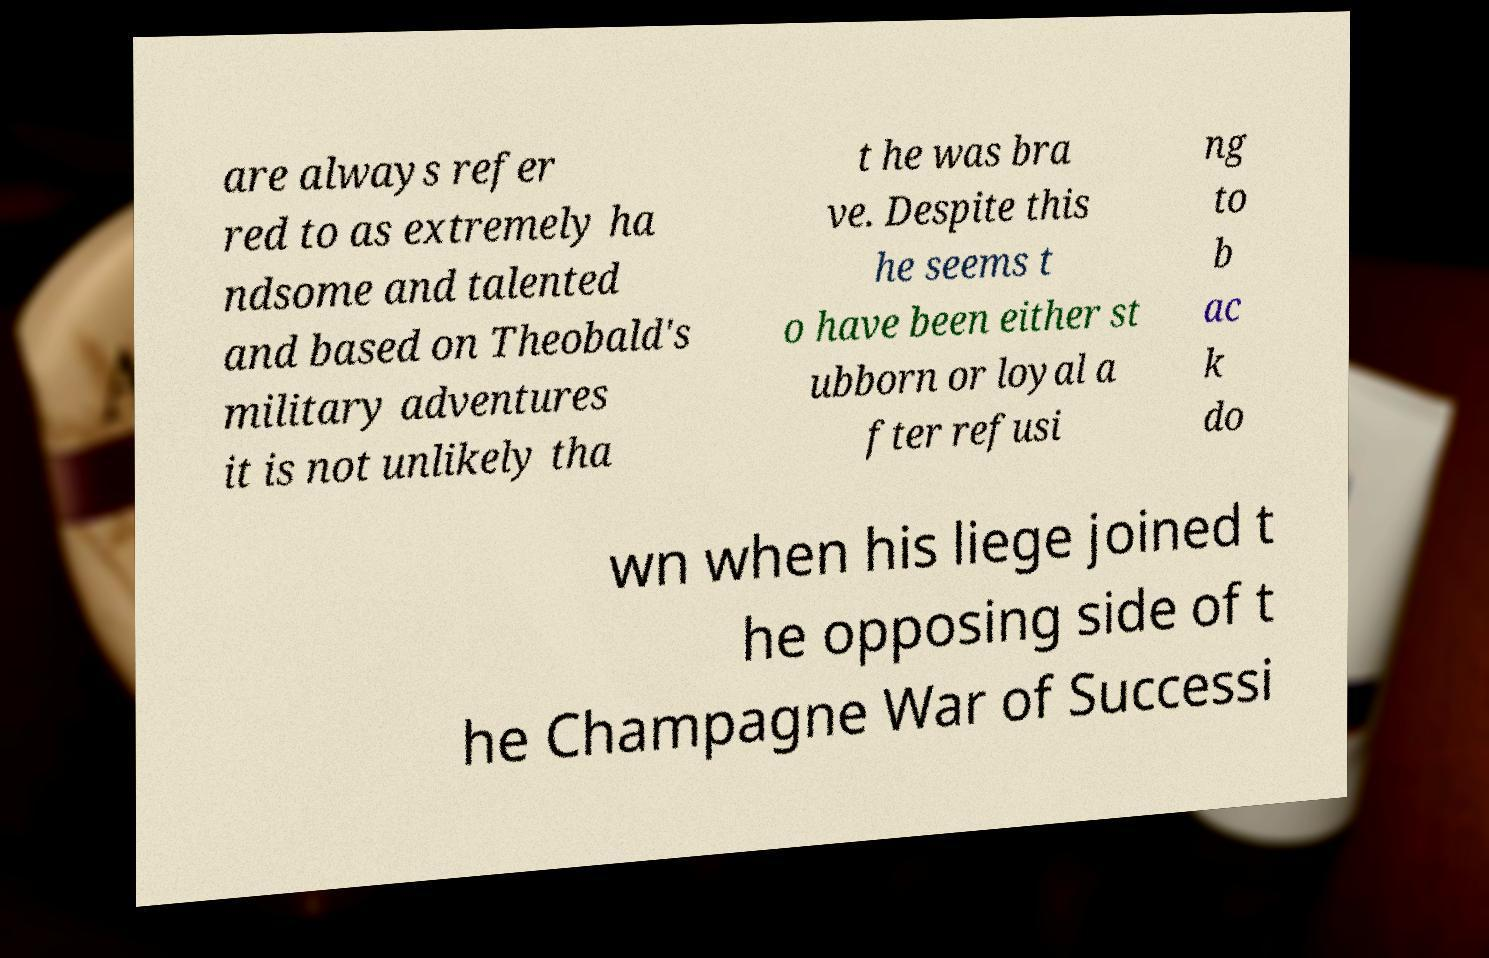Can you read and provide the text displayed in the image?This photo seems to have some interesting text. Can you extract and type it out for me? are always refer red to as extremely ha ndsome and talented and based on Theobald's military adventures it is not unlikely tha t he was bra ve. Despite this he seems t o have been either st ubborn or loyal a fter refusi ng to b ac k do wn when his liege joined t he opposing side of t he Champagne War of Successi 